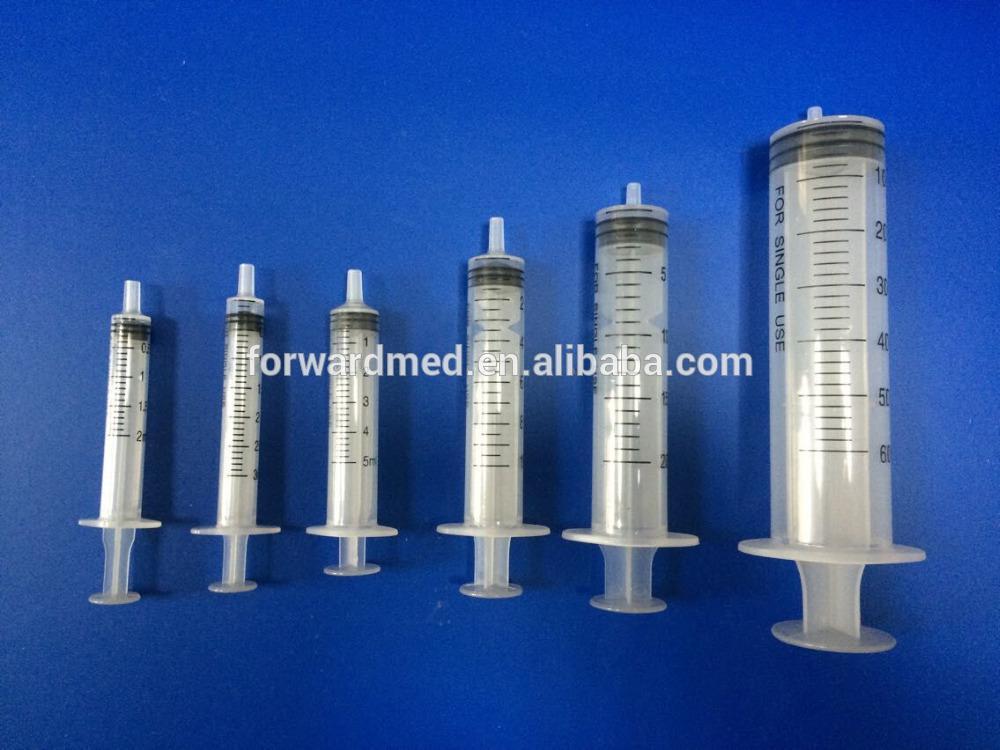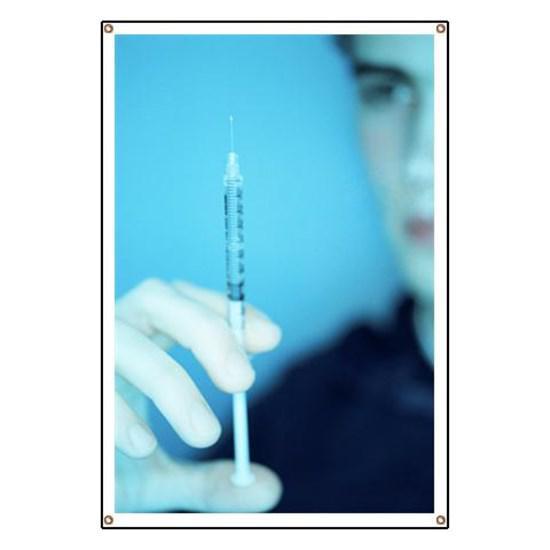The first image is the image on the left, the second image is the image on the right. Evaluate the accuracy of this statement regarding the images: "There are seven syringes.". Is it true? Answer yes or no. Yes. The first image is the image on the left, the second image is the image on the right. Examine the images to the left and right. Is the description "There is exactly one syringe with an uncapped needle." accurate? Answer yes or no. Yes. 